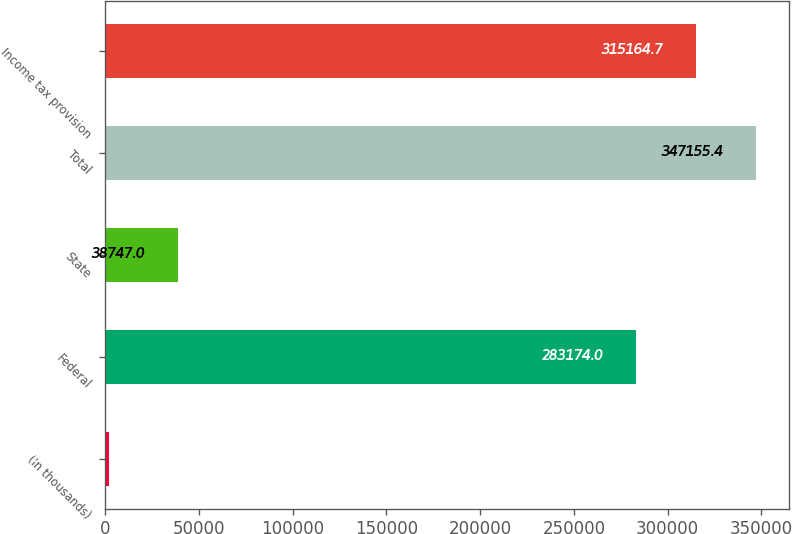Convert chart to OTSL. <chart><loc_0><loc_0><loc_500><loc_500><bar_chart><fcel>(In thousands)<fcel>Federal<fcel>State<fcel>Total<fcel>Income tax provision<nl><fcel>2014<fcel>283174<fcel>38747<fcel>347155<fcel>315165<nl></chart> 